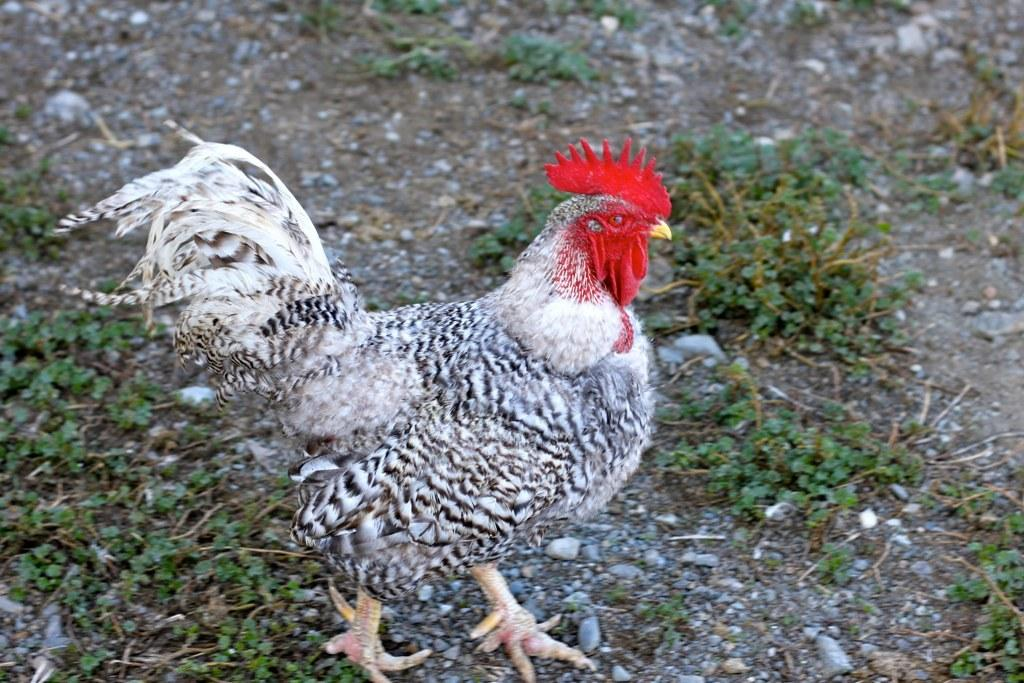What type of animal is in the picture? There is a hen in the picture. What else can be seen in the picture besides the hen? There are plants and stones on the ground in the picture. Can you see any mice running through the quicksand in the image? There is no quicksand or mice present in the image. 